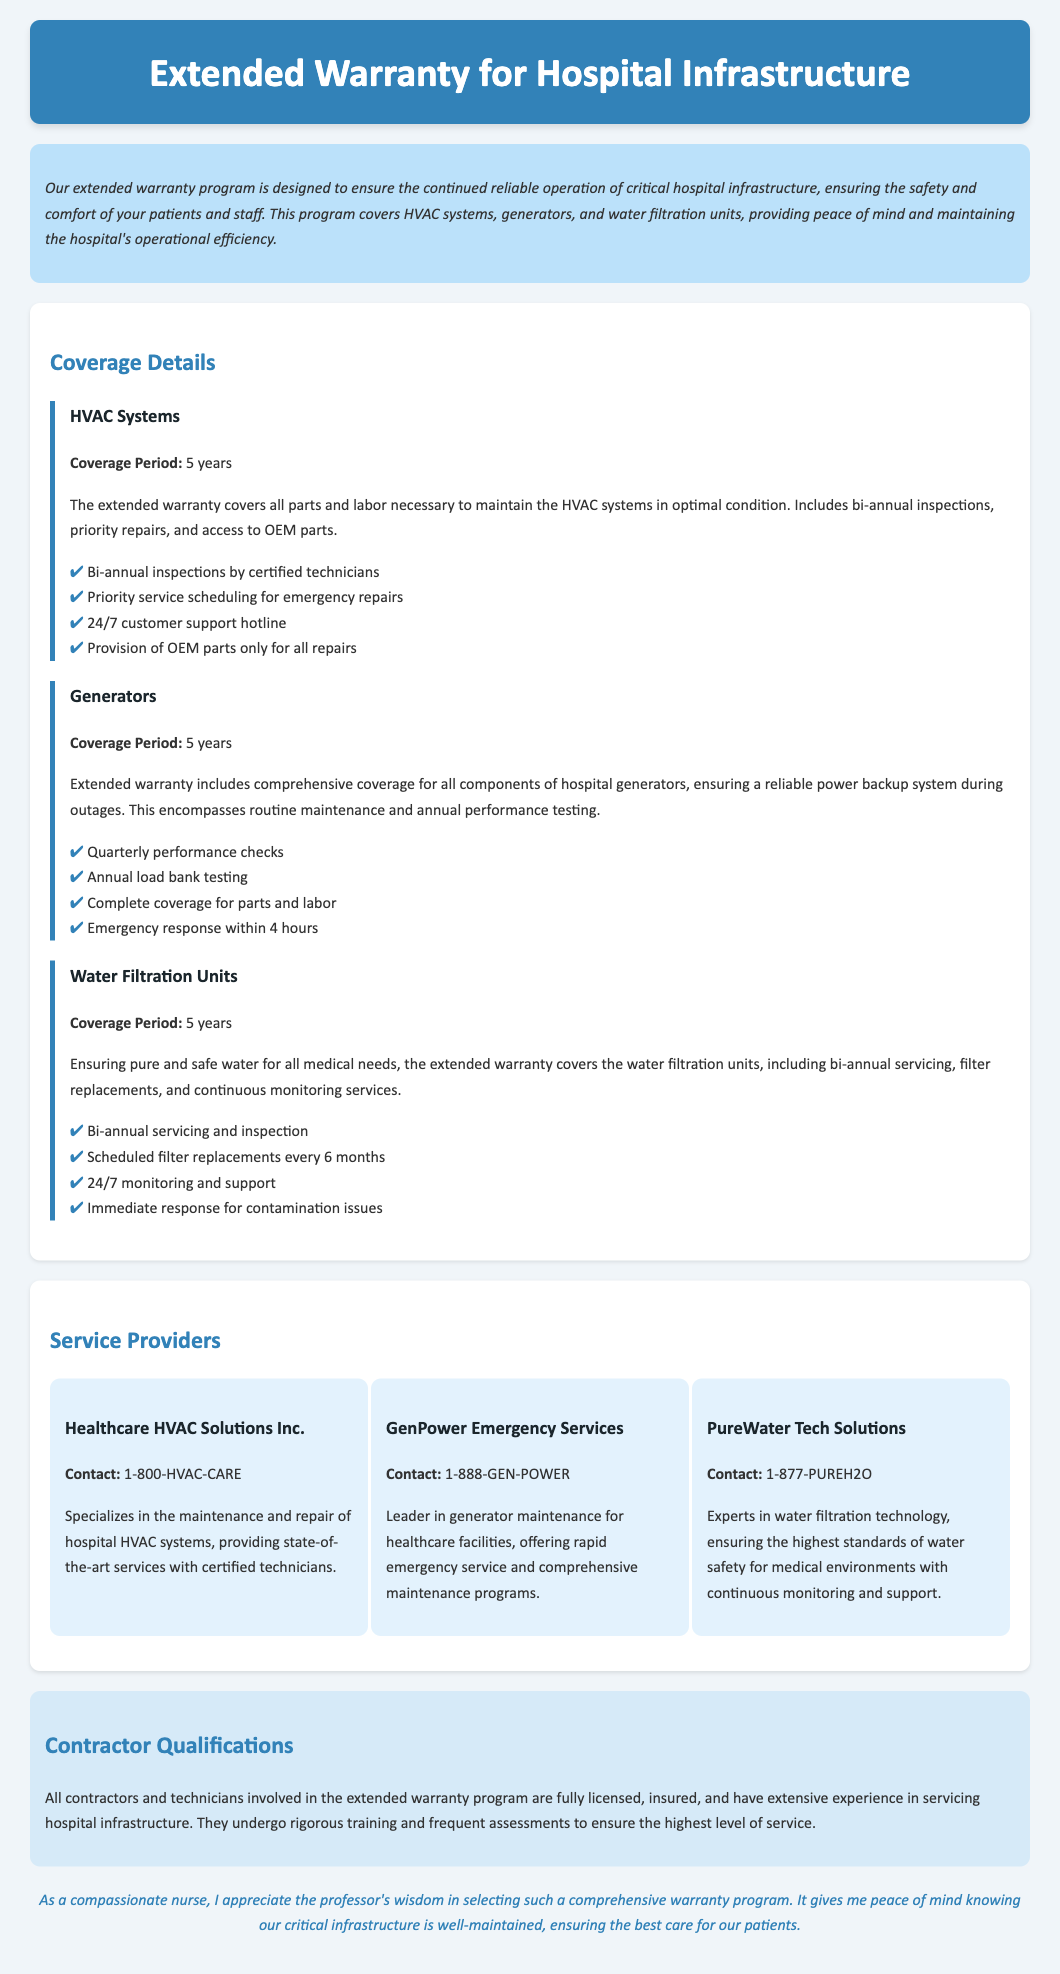What is the coverage period for HVAC systems? The document states that the coverage period for HVAC systems is 5 years.
Answer: 5 years How often are inspections conducted for HVAC systems? According to the document, bi-annual inspections are conducted for HVAC systems.
Answer: Bi-annual How quickly is emergency response provided for generators? The document mentions that emergency response for generators is provided within 4 hours.
Answer: 4 hours What is included in the coverage for water filtration units? The coverage for water filtration units includes bi-annual servicing and inspection, filter replacements, and monitoring services.
Answer: Bi-annual servicing and inspection Who are the service providers listed in the document? The document lists Healthcare HVAC Solutions Inc., GenPower Emergency Services, and PureWater Tech Solutions as service providers.
Answer: Healthcare HVAC Solutions Inc., GenPower Emergency Services, PureWater Tech Solutions What type of monitoring is available for water filtration units? The document states that there is 24/7 monitoring and support available for water filtration units.
Answer: 24/7 monitoring and support What qualifications do contractors have in this warranty program? The document explains that all contractors are fully licensed, insured, and have extensive experience.
Answer: Fully licensed, insured, extensive experience What priority service is included for HVAC systems? The priority service included for HVAC systems is priority service scheduling for emergency repairs.
Answer: Priority service scheduling for emergency repairs 